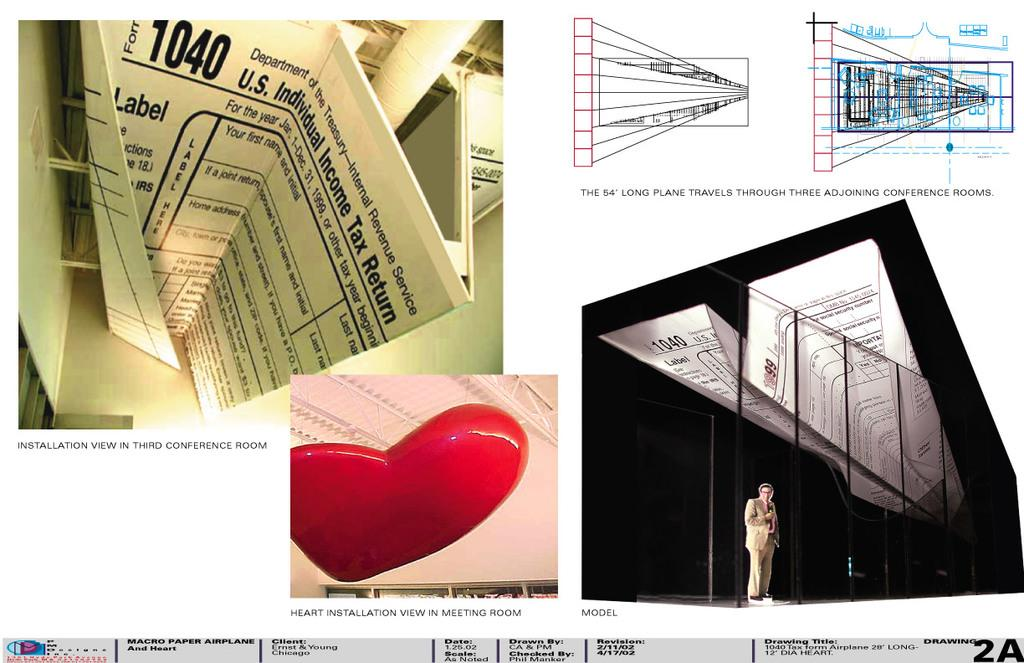<image>
Create a compact narrative representing the image presented. A paper airplane made out of a 1040 United States tax form. 